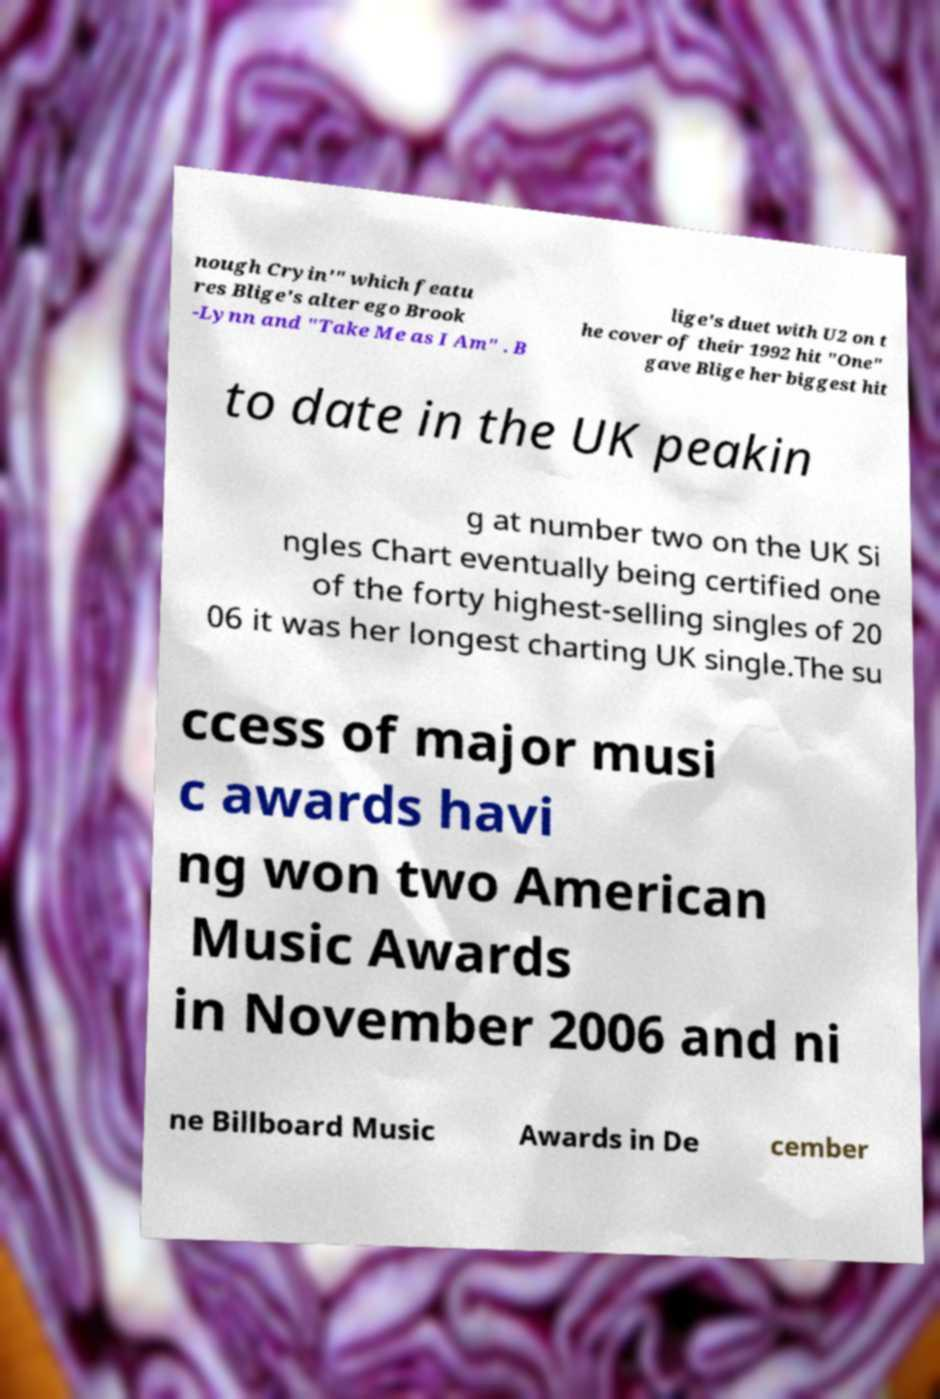Can you accurately transcribe the text from the provided image for me? nough Cryin'" which featu res Blige's alter ego Brook -Lynn and "Take Me as I Am" . B lige's duet with U2 on t he cover of their 1992 hit "One" gave Blige her biggest hit to date in the UK peakin g at number two on the UK Si ngles Chart eventually being certified one of the forty highest-selling singles of 20 06 it was her longest charting UK single.The su ccess of major musi c awards havi ng won two American Music Awards in November 2006 and ni ne Billboard Music Awards in De cember 